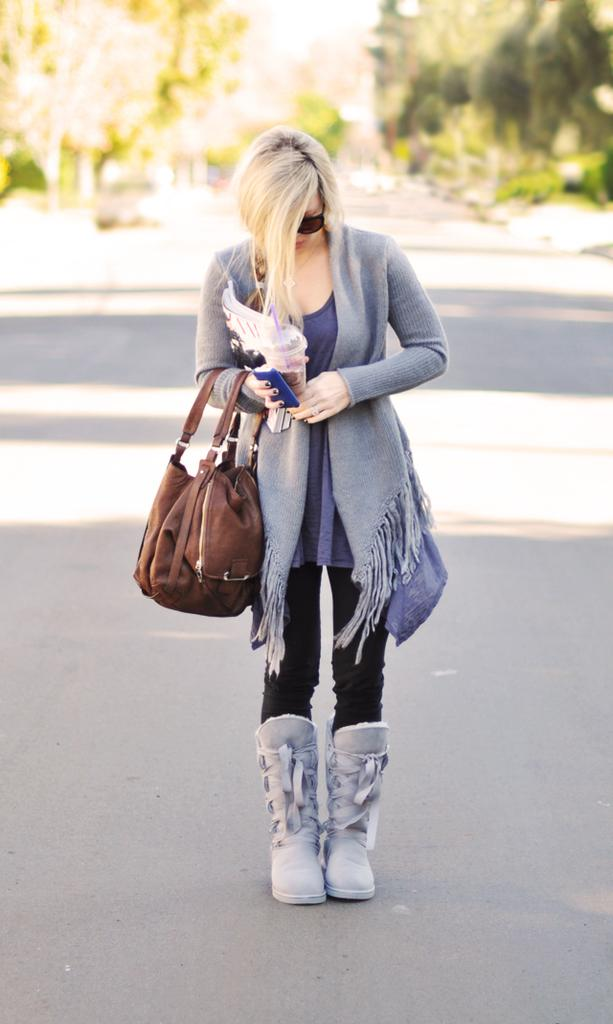What is the main subject of the image? The main subject of the image is a woman. What is the woman wearing on her face? The woman is wearing goggles. What objects is the woman holding in her hands? The woman is holding a glass, a mobile, a handbag, and some books. What type of footwear is the woman wearing? The woman is wearing boots. Where is the woman standing in the image? The woman is standing on a road. What can be seen in the background of the image? There are trees in the background of the image. What type of bead is the woman using to make observations in the image? There is no bead present in the image, and the woman is not making any observations. How many girls are visible in the image? There is only one woman visible in the image, not a girl. 